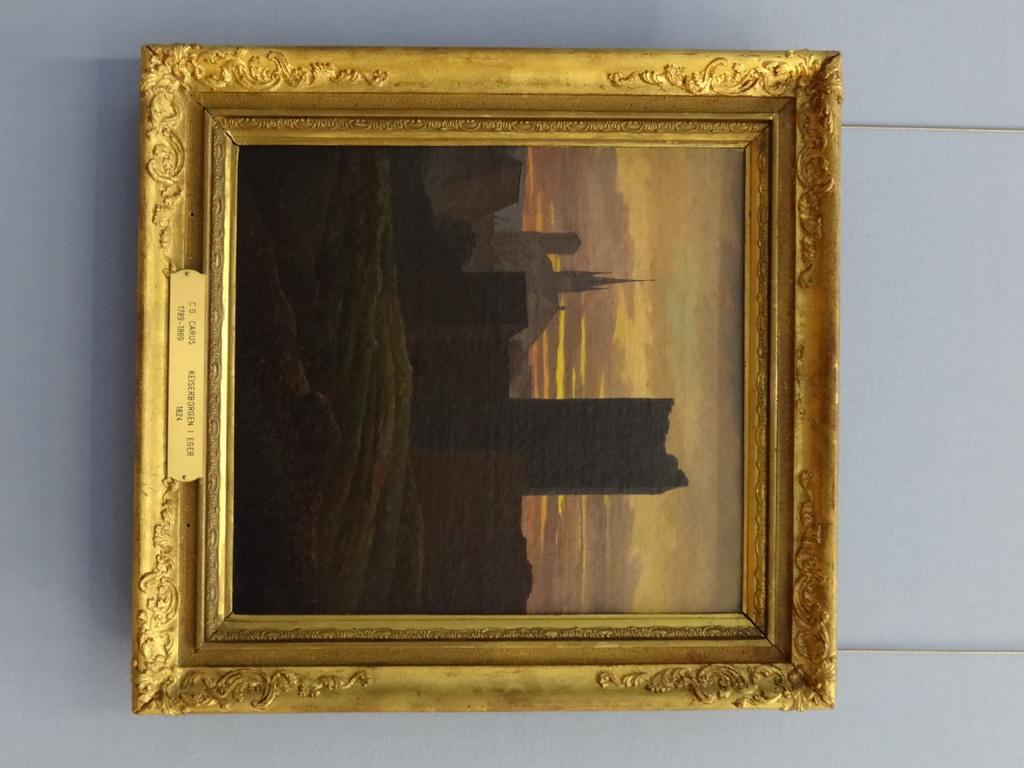What is located on the wall in the center of the image? There is a frame on the wall in the center of the image. What type of badge is attached to the frame in the image? There is no badge present in the image; it only features a frame on the wall. 